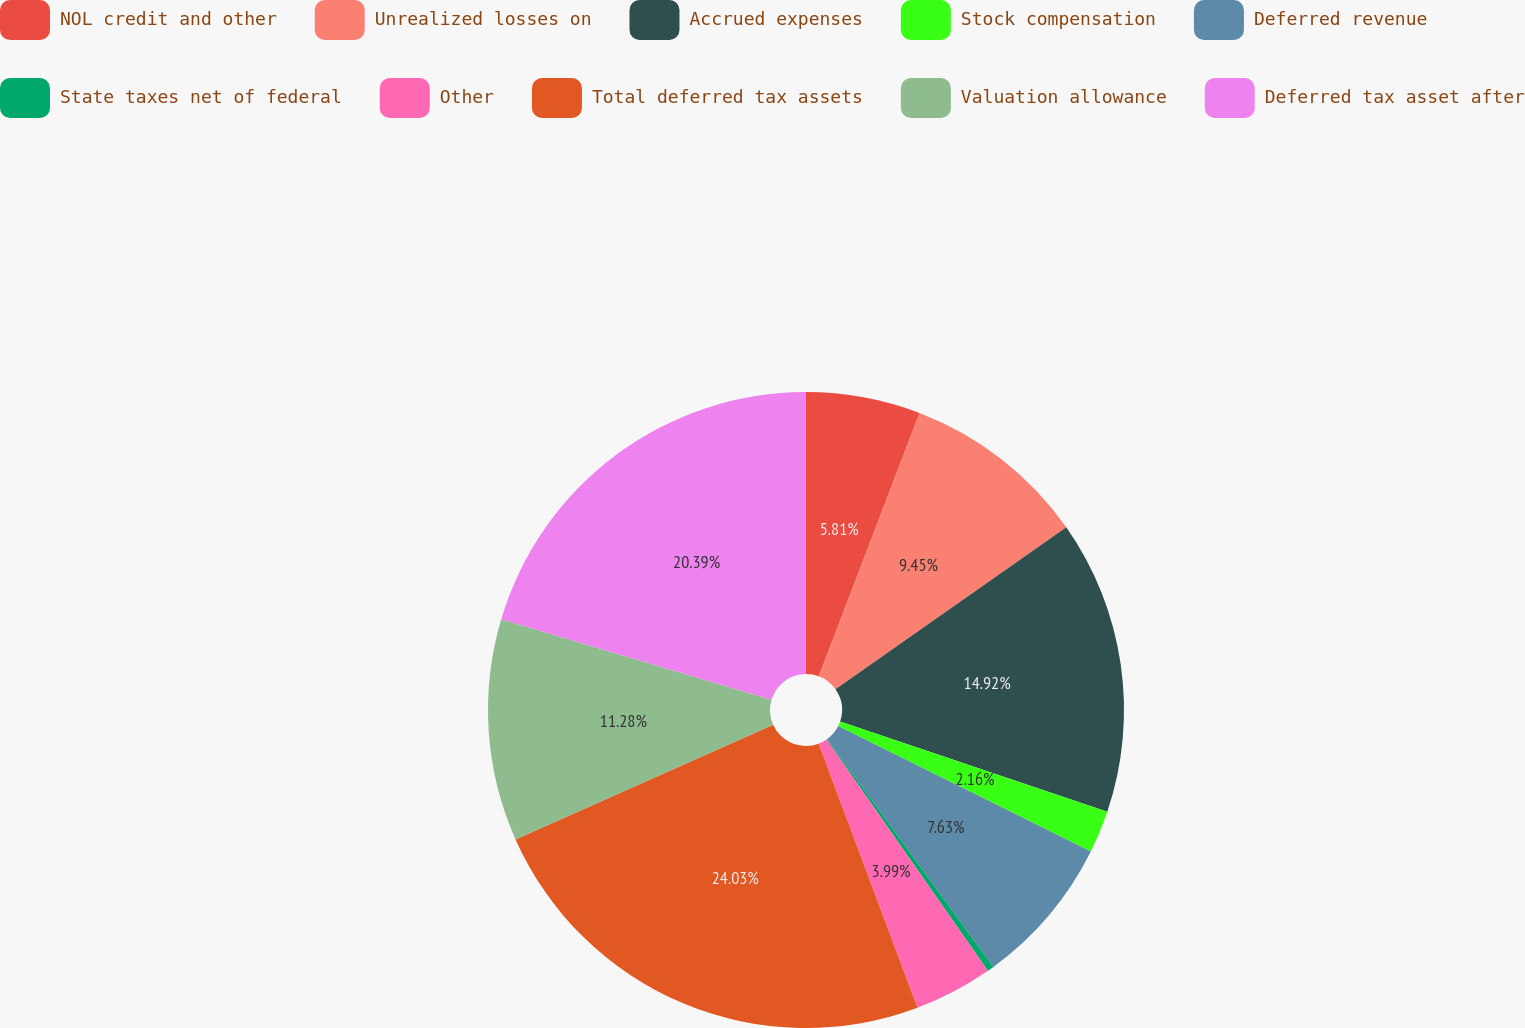Convert chart to OTSL. <chart><loc_0><loc_0><loc_500><loc_500><pie_chart><fcel>NOL credit and other<fcel>Unrealized losses on<fcel>Accrued expenses<fcel>Stock compensation<fcel>Deferred revenue<fcel>State taxes net of federal<fcel>Other<fcel>Total deferred tax assets<fcel>Valuation allowance<fcel>Deferred tax asset after<nl><fcel>5.81%<fcel>9.45%<fcel>14.92%<fcel>2.16%<fcel>7.63%<fcel>0.34%<fcel>3.99%<fcel>24.03%<fcel>11.28%<fcel>20.39%<nl></chart> 